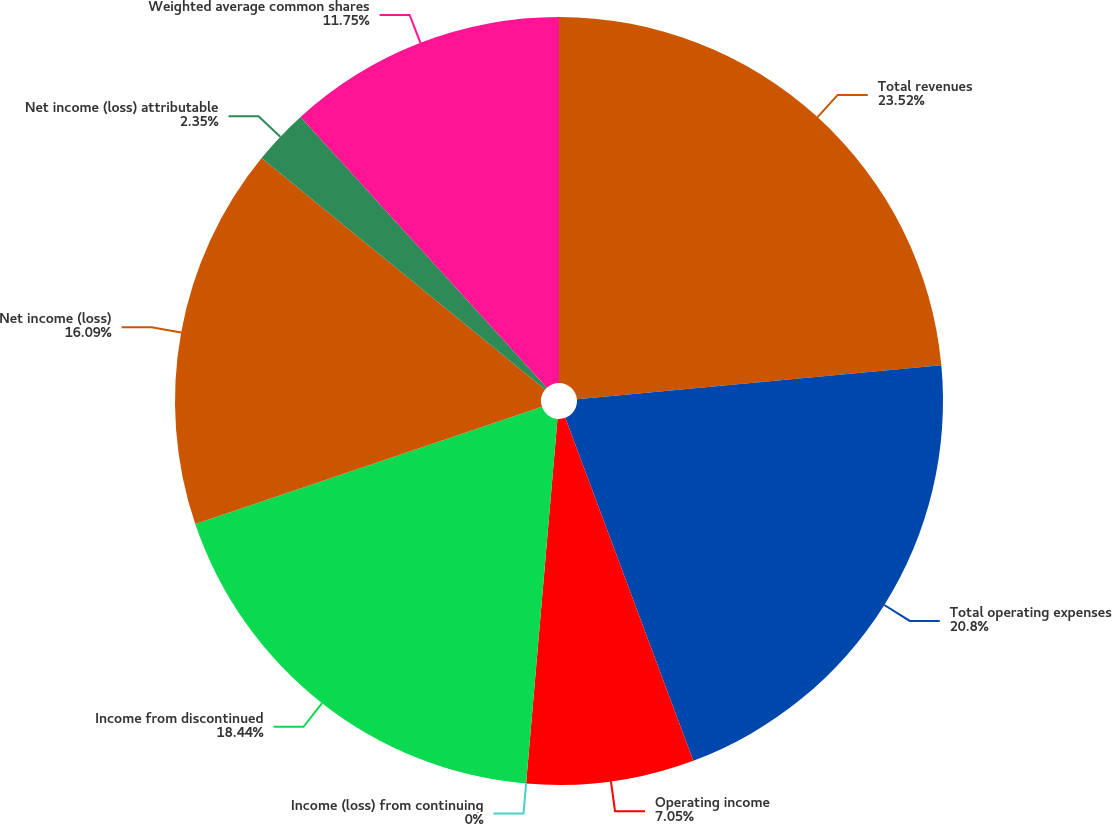<chart> <loc_0><loc_0><loc_500><loc_500><pie_chart><fcel>Total revenues<fcel>Total operating expenses<fcel>Operating income<fcel>Income (loss) from continuing<fcel>Income from discontinued<fcel>Net income (loss)<fcel>Net income (loss) attributable<fcel>Weighted average common shares<nl><fcel>23.51%<fcel>20.8%<fcel>7.05%<fcel>0.0%<fcel>18.44%<fcel>16.09%<fcel>2.35%<fcel>11.75%<nl></chart> 